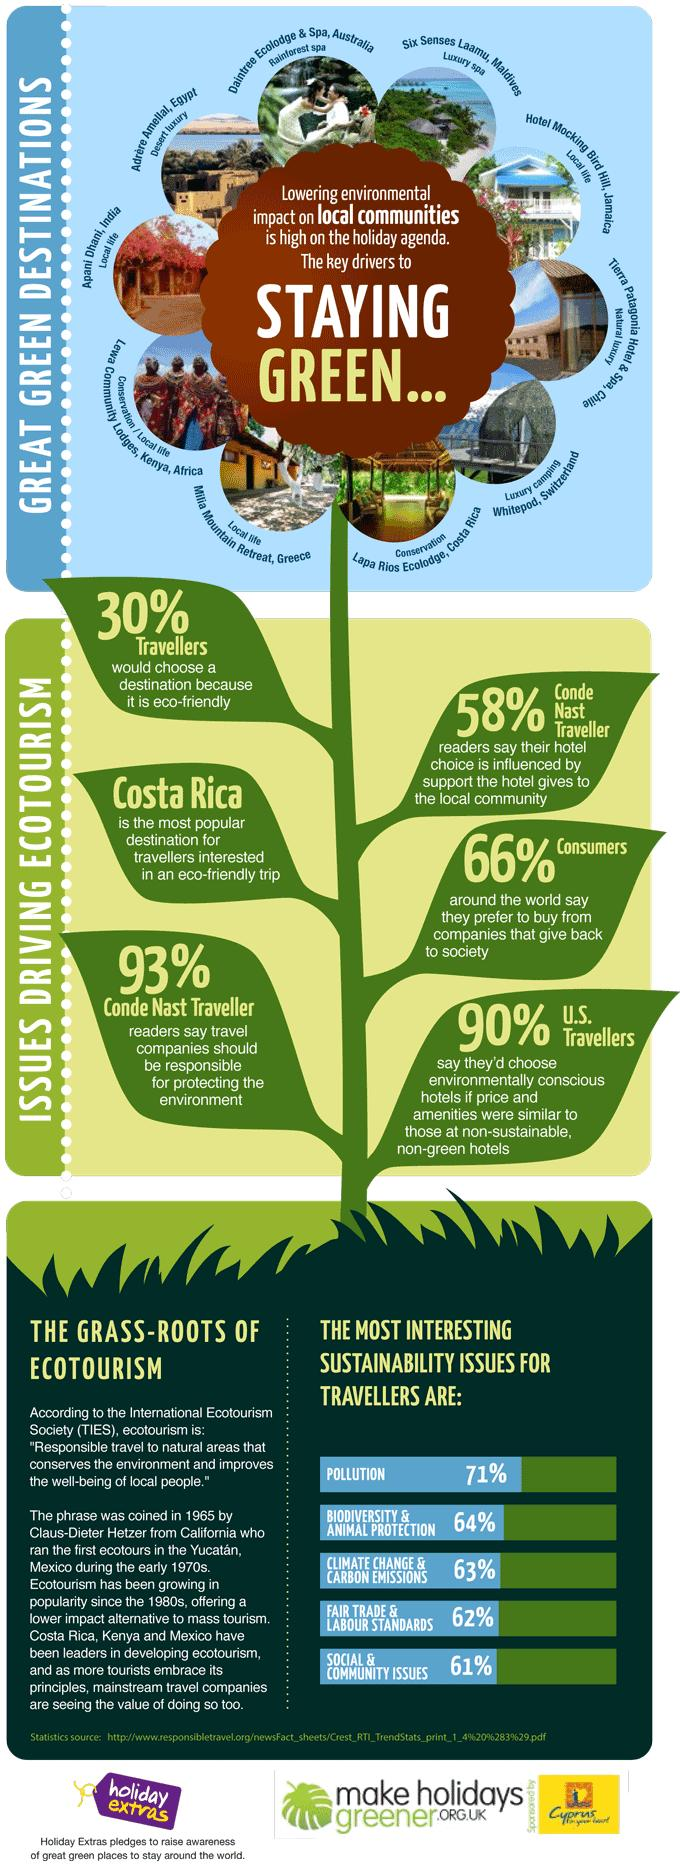Highlight a few significant elements in this photo. The impact of pollution and adherence to Fairtrade & Labour Standards on travelers is significant, with a significant percentage affecting their experience. According to a recent survey, 30% of travelers choose eco-friendly destinations. According to a recent survey, 66% of consumers prefer to buy from companies that give back to society. 